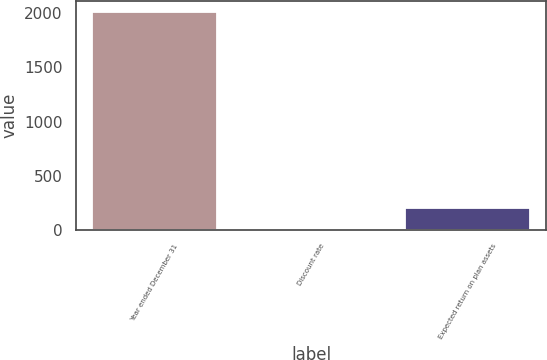Convert chart. <chart><loc_0><loc_0><loc_500><loc_500><bar_chart><fcel>Year ended December 31<fcel>Discount rate<fcel>Expected return on plan assets<nl><fcel>2015<fcel>3.5<fcel>204.65<nl></chart> 